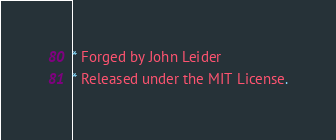Convert code to text. <code><loc_0><loc_0><loc_500><loc_500><_CSS_>* Forged by John Leider
* Released under the MIT License.</code> 